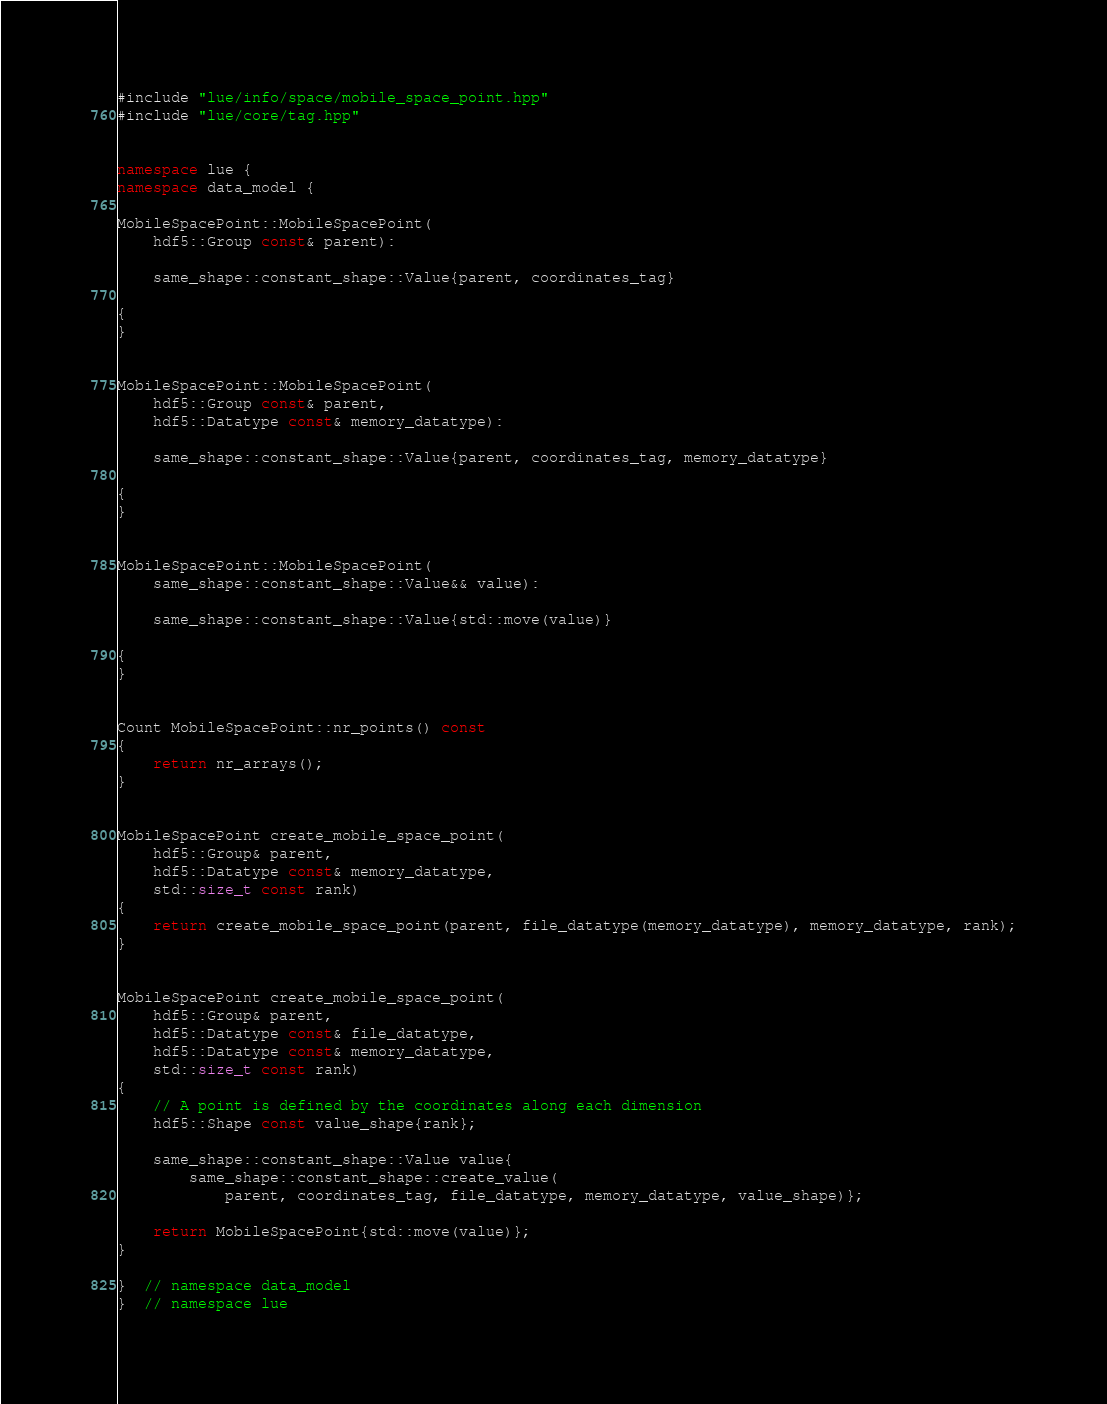Convert code to text. <code><loc_0><loc_0><loc_500><loc_500><_C++_>#include "lue/info/space/mobile_space_point.hpp"
#include "lue/core/tag.hpp"


namespace lue {
namespace data_model {

MobileSpacePoint::MobileSpacePoint(
    hdf5::Group const& parent):

    same_shape::constant_shape::Value{parent, coordinates_tag}

{
}


MobileSpacePoint::MobileSpacePoint(
    hdf5::Group const& parent,
    hdf5::Datatype const& memory_datatype):

    same_shape::constant_shape::Value{parent, coordinates_tag, memory_datatype}

{
}


MobileSpacePoint::MobileSpacePoint(
    same_shape::constant_shape::Value&& value):

    same_shape::constant_shape::Value{std::move(value)}

{
}


Count MobileSpacePoint::nr_points() const
{
    return nr_arrays();
}


MobileSpacePoint create_mobile_space_point(
    hdf5::Group& parent,
    hdf5::Datatype const& memory_datatype,
    std::size_t const rank)
{
    return create_mobile_space_point(parent, file_datatype(memory_datatype), memory_datatype, rank);
}


MobileSpacePoint create_mobile_space_point(
    hdf5::Group& parent,
    hdf5::Datatype const& file_datatype,
    hdf5::Datatype const& memory_datatype,
    std::size_t const rank)
{
    // A point is defined by the coordinates along each dimension
    hdf5::Shape const value_shape{rank};

    same_shape::constant_shape::Value value{
        same_shape::constant_shape::create_value(
            parent, coordinates_tag, file_datatype, memory_datatype, value_shape)};

    return MobileSpacePoint{std::move(value)};
}

}  // namespace data_model
}  // namespace lue
</code> 